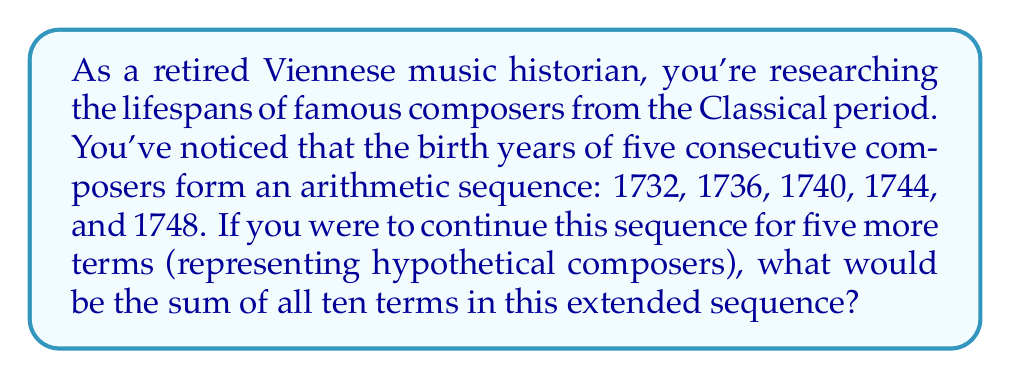Can you solve this math problem? Let's approach this step-by-step:

1) First, we need to identify the components of the arithmetic sequence:
   - $a_1 = 1732$ (first term)
   - $d = 4$ (common difference)
   - $n = 10$ (total number of terms)

2) For an arithmetic sequence, we can use the formula for the sum:

   $S_n = \frac{n}{2}(a_1 + a_n)$

   Where $a_n$ is the last term of the sequence.

3) To find $a_n$, we can use the formula:

   $a_n = a_1 + (n-1)d$

4) Let's calculate $a_{10}$:

   $a_{10} = 1732 + (10-1)4 = 1732 + 36 = 1768$

5) Now we can plug these values into our sum formula:

   $S_{10} = \frac{10}{2}(1732 + 1768)$

6) Simplify:

   $S_{10} = 5(3500) = 17500$

Therefore, the sum of all ten terms in the extended sequence is 17500.
Answer: $17500$ 